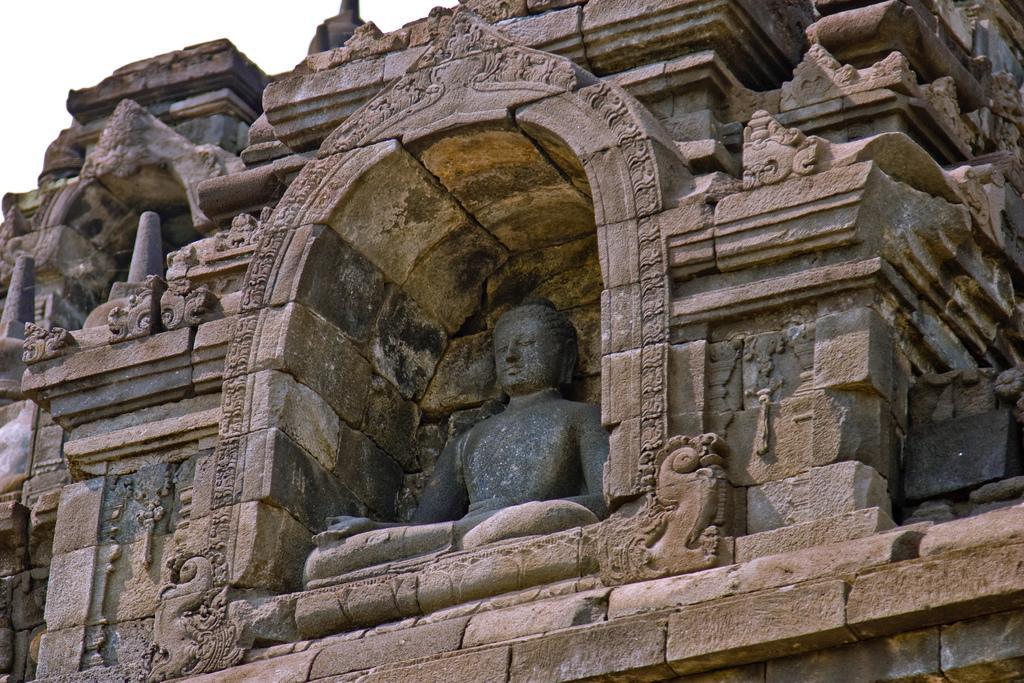Describe this image in one or two sentences. In this image in the center there is a building and in the center there is one statue of Buddha. 